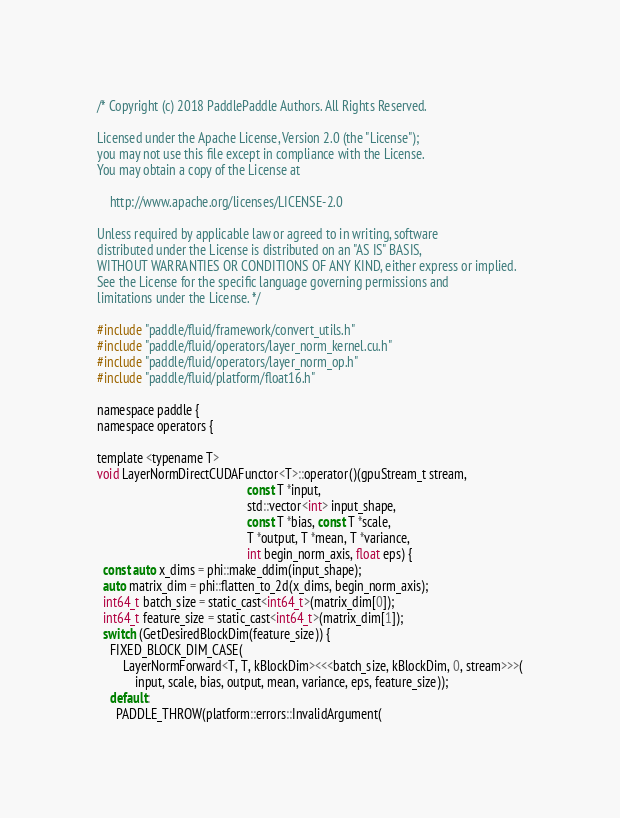Convert code to text. <code><loc_0><loc_0><loc_500><loc_500><_Cuda_>/* Copyright (c) 2018 PaddlePaddle Authors. All Rights Reserved.

Licensed under the Apache License, Version 2.0 (the "License");
you may not use this file except in compliance with the License.
You may obtain a copy of the License at

    http://www.apache.org/licenses/LICENSE-2.0

Unless required by applicable law or agreed to in writing, software
distributed under the License is distributed on an "AS IS" BASIS,
WITHOUT WARRANTIES OR CONDITIONS OF ANY KIND, either express or implied.
See the License for the specific language governing permissions and
limitations under the License. */

#include "paddle/fluid/framework/convert_utils.h"
#include "paddle/fluid/operators/layer_norm_kernel.cu.h"
#include "paddle/fluid/operators/layer_norm_op.h"
#include "paddle/fluid/platform/float16.h"

namespace paddle {
namespace operators {

template <typename T>
void LayerNormDirectCUDAFunctor<T>::operator()(gpuStream_t stream,
                                               const T *input,
                                               std::vector<int> input_shape,
                                               const T *bias, const T *scale,
                                               T *output, T *mean, T *variance,
                                               int begin_norm_axis, float eps) {
  const auto x_dims = phi::make_ddim(input_shape);
  auto matrix_dim = phi::flatten_to_2d(x_dims, begin_norm_axis);
  int64_t batch_size = static_cast<int64_t>(matrix_dim[0]);
  int64_t feature_size = static_cast<int64_t>(matrix_dim[1]);
  switch (GetDesiredBlockDim(feature_size)) {
    FIXED_BLOCK_DIM_CASE(
        LayerNormForward<T, T, kBlockDim><<<batch_size, kBlockDim, 0, stream>>>(
            input, scale, bias, output, mean, variance, eps, feature_size));
    default:
      PADDLE_THROW(platform::errors::InvalidArgument(</code> 